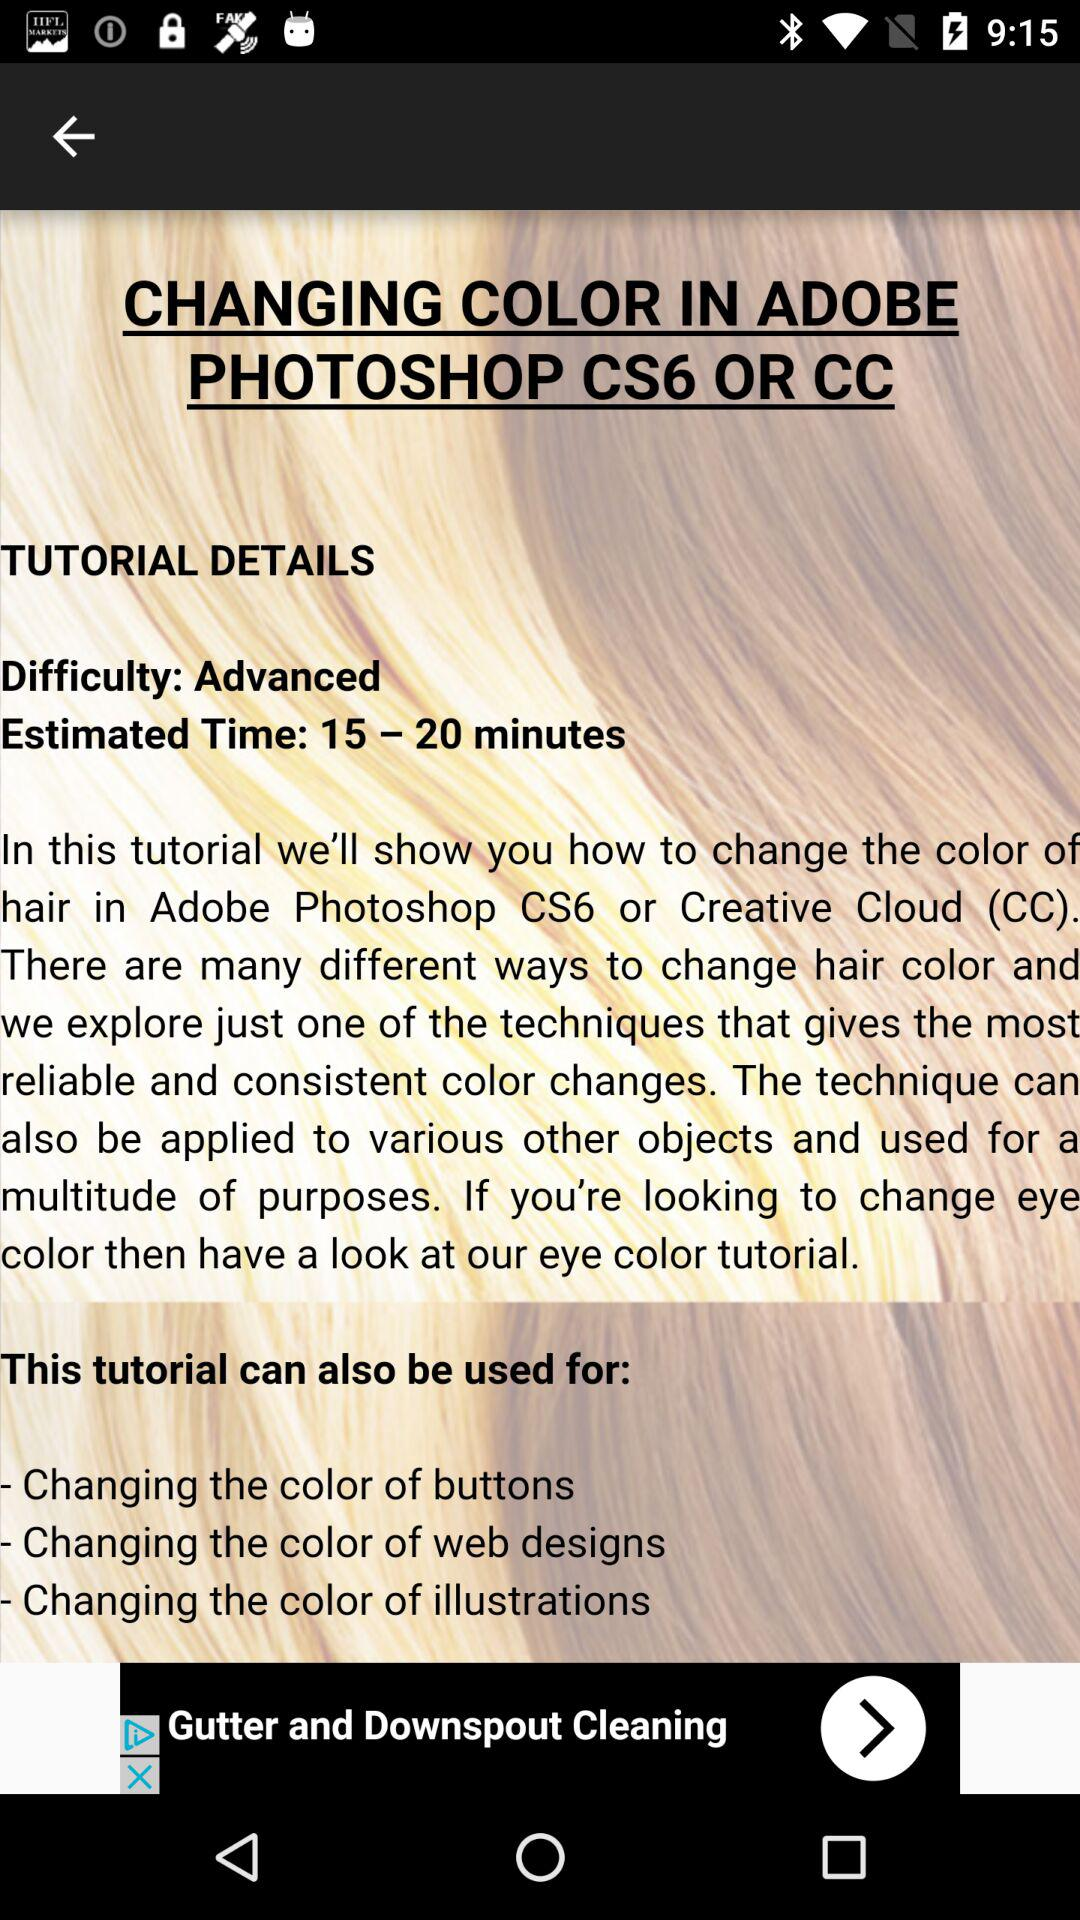What is the estimated duration? The estimated duration is 15 minutes to 20 minutes. 